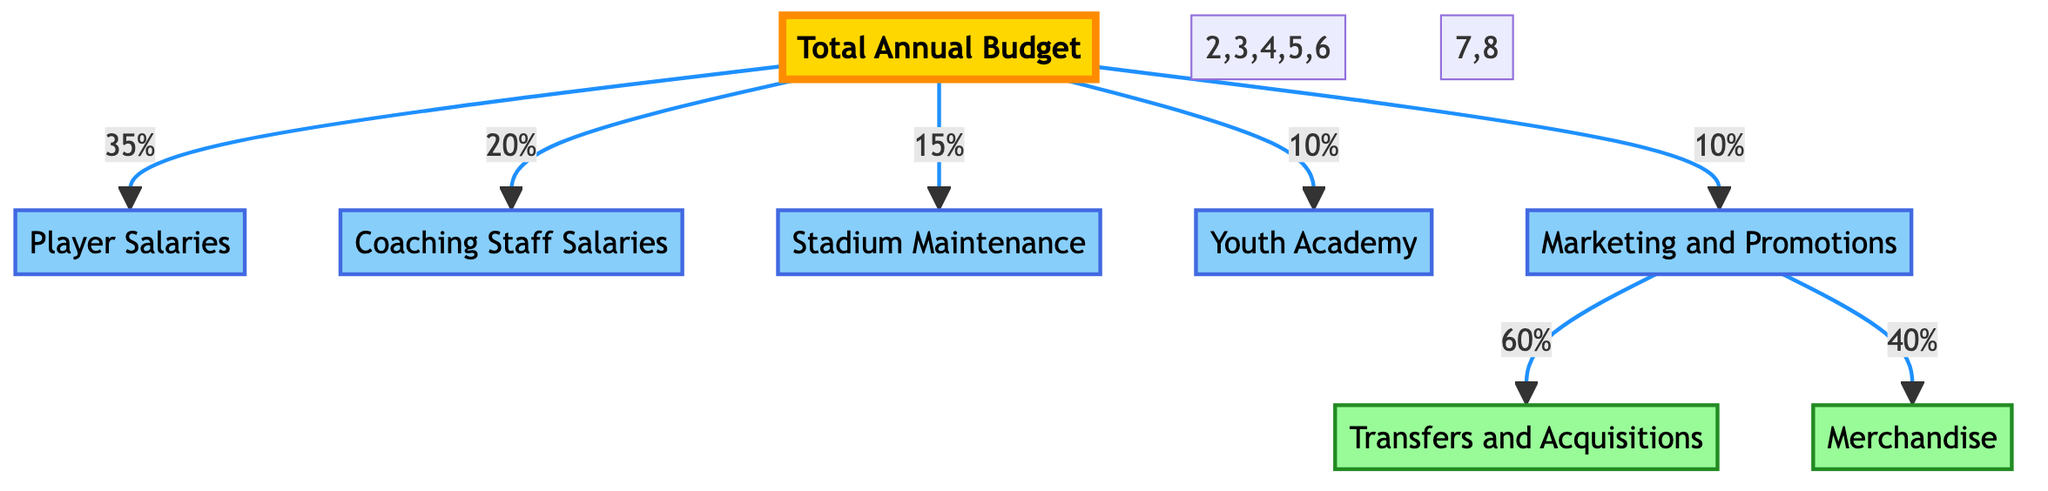What percentage of the total annual budget is allocated to player salaries? The diagram shows that player salaries receive 35% of the total annual budget.
Answer: 35% How many main categories are there in the budget allocation? The diagram depicts six main categories stemming from the total annual budget, which are player salaries, coaching staff salaries, stadium maintenance, youth academy, marketing and promotions, and additional details for marketing and promotions.
Answer: 6 What is the percentage of the budget dedicated to youth academy? The youth academy is allocated 10% of the total annual budget, according to the diagram.
Answer: 10% Which category receives the least budget allocation? The stadium maintenance receives 15%, which is less than player and coaching staff salaries, and more than youth academy and marketing and promotions. Therefore, among the main categories, youth academy gets the least budget allocation at 10%.
Answer: Youth Academy What percentage of the marketing and promotions budget is spent on transfers and acquisitions? The marketing and promotions budget is divided into two parts: 60% for transfers and acquisitions and 40% for merchandise. Therefore, within marketing and promotions, transfers and acquisitions receive 60% of that budget.
Answer: 60% Which two budget categories directly receive a percentage from the total annual budget? The categories that get direct allocations from the total annual budget are player salaries and coaching staff salaries, receiving 35% and 20% respectively.
Answer: Player Salaries and Coaching Staff Salaries What is the combined percentage of the budget allocated for stadium maintenance and youth academy? Stadium maintenance receives 15%, while the youth academy gets 10%, so the combined percentage is 15% + 10%, which equals 25%.
Answer: 25% What does the total annual budget amount to when considering the percentage distributions? Since all percentages total up to 100%, the total annual budget can be inferred directly from these distributions; percentages alone indicate that all allocations sum to 100%.
Answer: 100% 